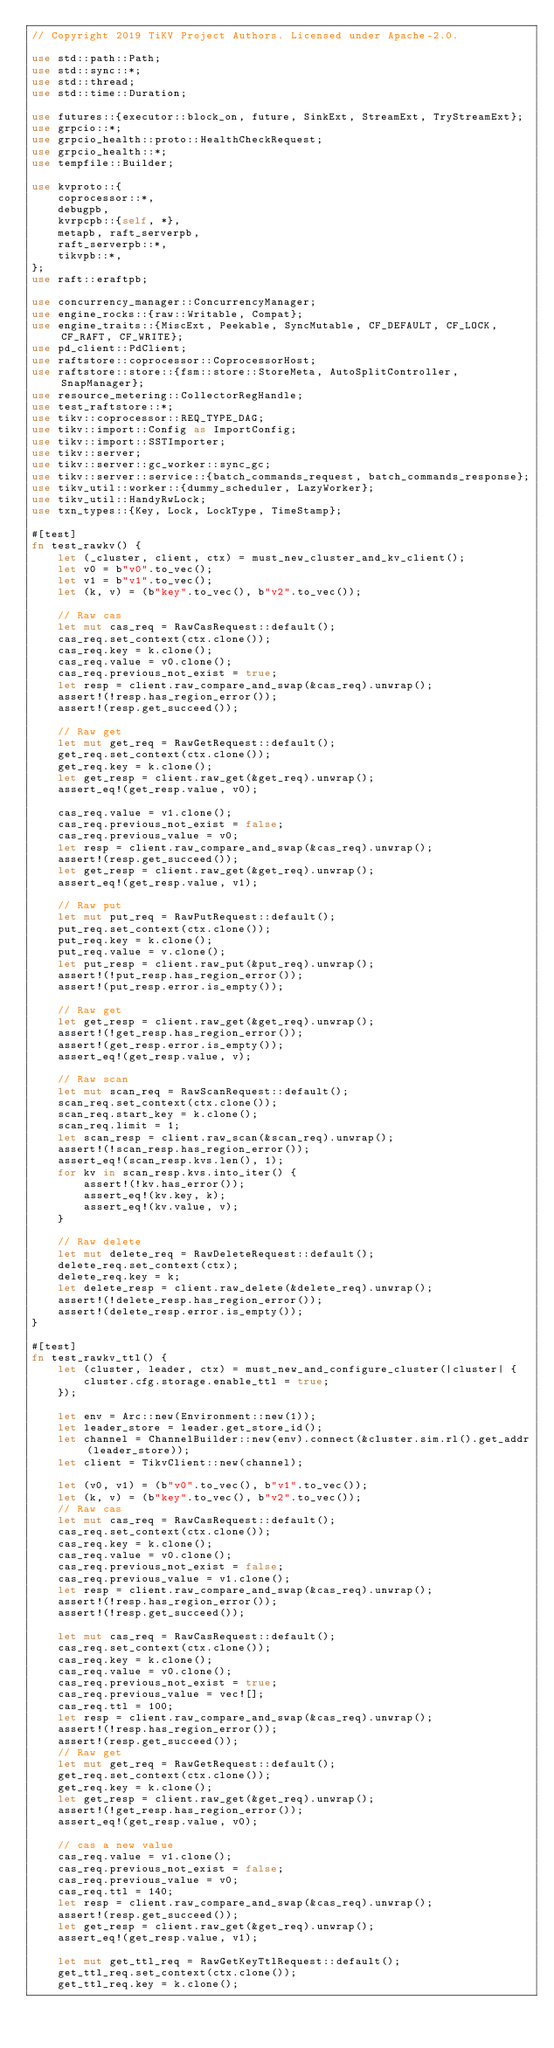Convert code to text. <code><loc_0><loc_0><loc_500><loc_500><_Rust_>// Copyright 2019 TiKV Project Authors. Licensed under Apache-2.0.

use std::path::Path;
use std::sync::*;
use std::thread;
use std::time::Duration;

use futures::{executor::block_on, future, SinkExt, StreamExt, TryStreamExt};
use grpcio::*;
use grpcio_health::proto::HealthCheckRequest;
use grpcio_health::*;
use tempfile::Builder;

use kvproto::{
    coprocessor::*,
    debugpb,
    kvrpcpb::{self, *},
    metapb, raft_serverpb,
    raft_serverpb::*,
    tikvpb::*,
};
use raft::eraftpb;

use concurrency_manager::ConcurrencyManager;
use engine_rocks::{raw::Writable, Compat};
use engine_traits::{MiscExt, Peekable, SyncMutable, CF_DEFAULT, CF_LOCK, CF_RAFT, CF_WRITE};
use pd_client::PdClient;
use raftstore::coprocessor::CoprocessorHost;
use raftstore::store::{fsm::store::StoreMeta, AutoSplitController, SnapManager};
use resource_metering::CollectorRegHandle;
use test_raftstore::*;
use tikv::coprocessor::REQ_TYPE_DAG;
use tikv::import::Config as ImportConfig;
use tikv::import::SSTImporter;
use tikv::server;
use tikv::server::gc_worker::sync_gc;
use tikv::server::service::{batch_commands_request, batch_commands_response};
use tikv_util::worker::{dummy_scheduler, LazyWorker};
use tikv_util::HandyRwLock;
use txn_types::{Key, Lock, LockType, TimeStamp};

#[test]
fn test_rawkv() {
    let (_cluster, client, ctx) = must_new_cluster_and_kv_client();
    let v0 = b"v0".to_vec();
    let v1 = b"v1".to_vec();
    let (k, v) = (b"key".to_vec(), b"v2".to_vec());

    // Raw cas
    let mut cas_req = RawCasRequest::default();
    cas_req.set_context(ctx.clone());
    cas_req.key = k.clone();
    cas_req.value = v0.clone();
    cas_req.previous_not_exist = true;
    let resp = client.raw_compare_and_swap(&cas_req).unwrap();
    assert!(!resp.has_region_error());
    assert!(resp.get_succeed());

    // Raw get
    let mut get_req = RawGetRequest::default();
    get_req.set_context(ctx.clone());
    get_req.key = k.clone();
    let get_resp = client.raw_get(&get_req).unwrap();
    assert_eq!(get_resp.value, v0);

    cas_req.value = v1.clone();
    cas_req.previous_not_exist = false;
    cas_req.previous_value = v0;
    let resp = client.raw_compare_and_swap(&cas_req).unwrap();
    assert!(resp.get_succeed());
    let get_resp = client.raw_get(&get_req).unwrap();
    assert_eq!(get_resp.value, v1);

    // Raw put
    let mut put_req = RawPutRequest::default();
    put_req.set_context(ctx.clone());
    put_req.key = k.clone();
    put_req.value = v.clone();
    let put_resp = client.raw_put(&put_req).unwrap();
    assert!(!put_resp.has_region_error());
    assert!(put_resp.error.is_empty());

    // Raw get
    let get_resp = client.raw_get(&get_req).unwrap();
    assert!(!get_resp.has_region_error());
    assert!(get_resp.error.is_empty());
    assert_eq!(get_resp.value, v);

    // Raw scan
    let mut scan_req = RawScanRequest::default();
    scan_req.set_context(ctx.clone());
    scan_req.start_key = k.clone();
    scan_req.limit = 1;
    let scan_resp = client.raw_scan(&scan_req).unwrap();
    assert!(!scan_resp.has_region_error());
    assert_eq!(scan_resp.kvs.len(), 1);
    for kv in scan_resp.kvs.into_iter() {
        assert!(!kv.has_error());
        assert_eq!(kv.key, k);
        assert_eq!(kv.value, v);
    }

    // Raw delete
    let mut delete_req = RawDeleteRequest::default();
    delete_req.set_context(ctx);
    delete_req.key = k;
    let delete_resp = client.raw_delete(&delete_req).unwrap();
    assert!(!delete_resp.has_region_error());
    assert!(delete_resp.error.is_empty());
}

#[test]
fn test_rawkv_ttl() {
    let (cluster, leader, ctx) = must_new_and_configure_cluster(|cluster| {
        cluster.cfg.storage.enable_ttl = true;
    });

    let env = Arc::new(Environment::new(1));
    let leader_store = leader.get_store_id();
    let channel = ChannelBuilder::new(env).connect(&cluster.sim.rl().get_addr(leader_store));
    let client = TikvClient::new(channel);

    let (v0, v1) = (b"v0".to_vec(), b"v1".to_vec());
    let (k, v) = (b"key".to_vec(), b"v2".to_vec());
    // Raw cas
    let mut cas_req = RawCasRequest::default();
    cas_req.set_context(ctx.clone());
    cas_req.key = k.clone();
    cas_req.value = v0.clone();
    cas_req.previous_not_exist = false;
    cas_req.previous_value = v1.clone();
    let resp = client.raw_compare_and_swap(&cas_req).unwrap();
    assert!(!resp.has_region_error());
    assert!(!resp.get_succeed());

    let mut cas_req = RawCasRequest::default();
    cas_req.set_context(ctx.clone());
    cas_req.key = k.clone();
    cas_req.value = v0.clone();
    cas_req.previous_not_exist = true;
    cas_req.previous_value = vec![];
    cas_req.ttl = 100;
    let resp = client.raw_compare_and_swap(&cas_req).unwrap();
    assert!(!resp.has_region_error());
    assert!(resp.get_succeed());
    // Raw get
    let mut get_req = RawGetRequest::default();
    get_req.set_context(ctx.clone());
    get_req.key = k.clone();
    let get_resp = client.raw_get(&get_req).unwrap();
    assert!(!get_resp.has_region_error());
    assert_eq!(get_resp.value, v0);

    // cas a new value
    cas_req.value = v1.clone();
    cas_req.previous_not_exist = false;
    cas_req.previous_value = v0;
    cas_req.ttl = 140;
    let resp = client.raw_compare_and_swap(&cas_req).unwrap();
    assert!(resp.get_succeed());
    let get_resp = client.raw_get(&get_req).unwrap();
    assert_eq!(get_resp.value, v1);

    let mut get_ttl_req = RawGetKeyTtlRequest::default();
    get_ttl_req.set_context(ctx.clone());
    get_ttl_req.key = k.clone();</code> 